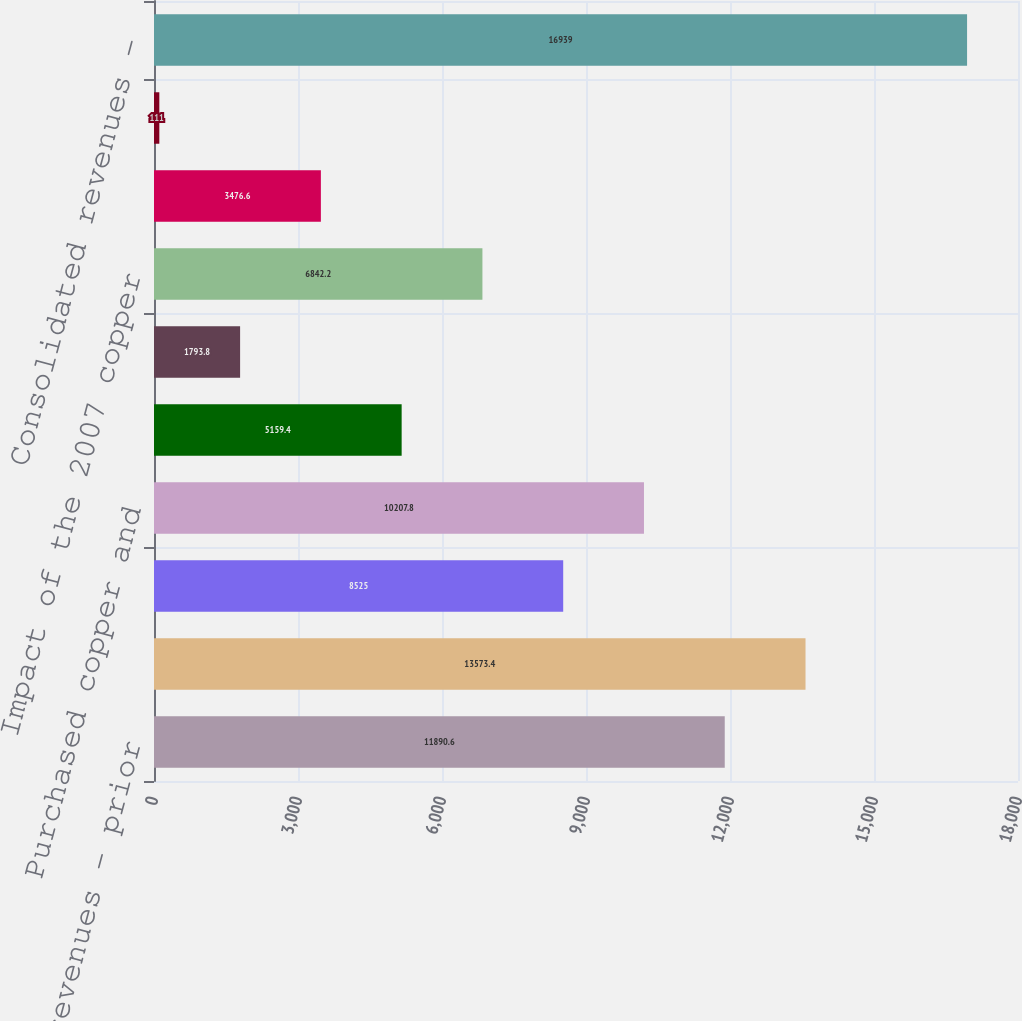Convert chart. <chart><loc_0><loc_0><loc_500><loc_500><bar_chart><fcel>Consolidated revenues - prior<fcel>Copper<fcel>Gold<fcel>Purchased copper and<fcel>Adjustments primarily for<fcel>Treatment charges<fcel>Impact of the 2007 copper<fcel>Atlantic Copper revenues<fcel>Other net<fcel>Consolidated revenues -<nl><fcel>11890.6<fcel>13573.4<fcel>8525<fcel>10207.8<fcel>5159.4<fcel>1793.8<fcel>6842.2<fcel>3476.6<fcel>111<fcel>16939<nl></chart> 